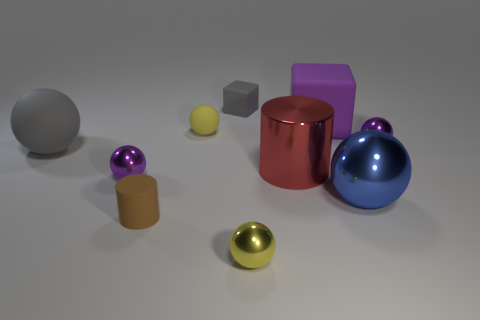How many objects are big purple matte objects or gray matte balls?
Give a very brief answer. 2. Does the brown matte cylinder have the same size as the gray rubber thing behind the gray ball?
Offer a very short reply. Yes. What is the size of the metal ball that is to the left of the tiny yellow ball that is in front of the purple thing to the left of the yellow metal ball?
Keep it short and to the point. Small. Are any big purple cylinders visible?
Keep it short and to the point. No. What material is the small cube that is the same color as the big matte sphere?
Ensure brevity in your answer.  Rubber. What number of large matte objects are the same color as the small matte cube?
Provide a short and direct response. 1. How many things are either rubber objects that are right of the gray matte block or metal things that are on the right side of the big purple matte block?
Provide a succinct answer. 3. How many things are to the left of the yellow ball that is behind the blue metal object?
Keep it short and to the point. 3. What is the color of the big cylinder that is the same material as the blue ball?
Provide a short and direct response. Red. Are there any yellow shiny objects of the same size as the rubber cylinder?
Offer a very short reply. Yes. 